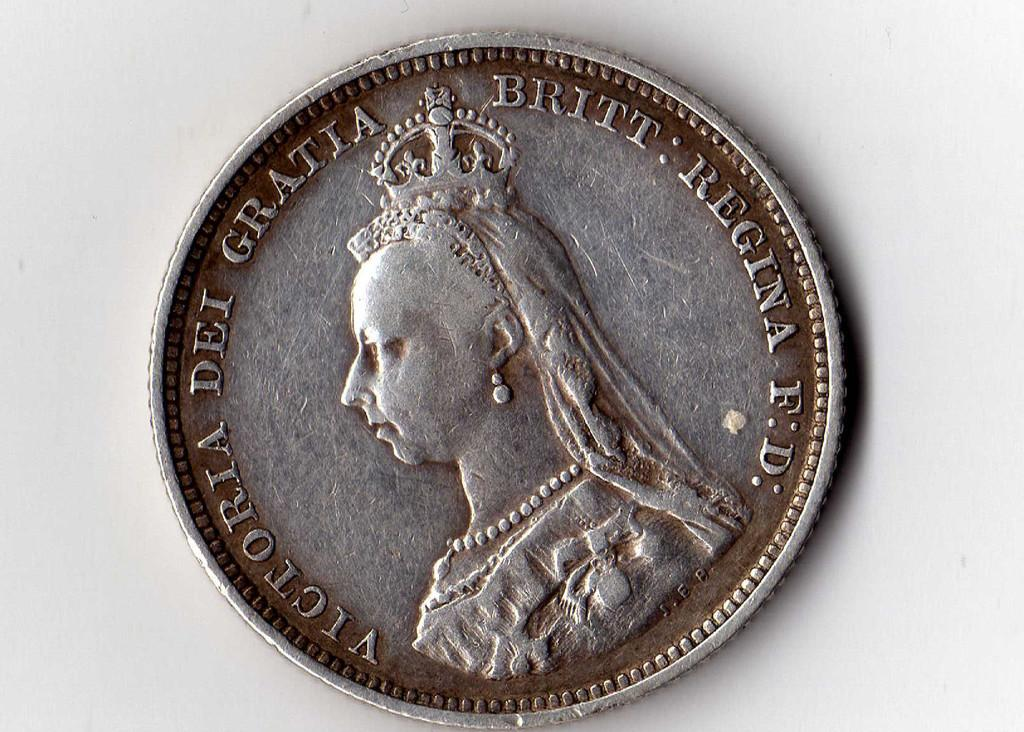<image>
Provide a brief description of the given image. The old silver coin shown here has a picture and writing of Victoria. 